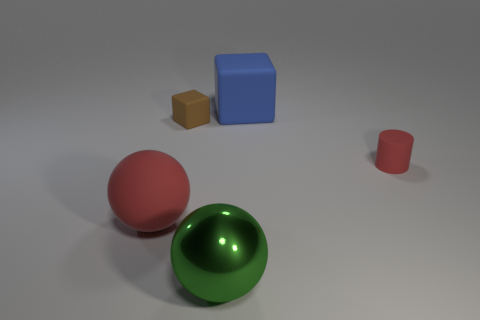There is a big ball that is the same color as the tiny matte cylinder; what is it made of?
Provide a succinct answer. Rubber. There is a object that is behind the small thing behind the small red matte object; what is its size?
Your answer should be compact. Large. Are there the same number of blue rubber things that are behind the shiny ball and shiny balls behind the rubber ball?
Offer a very short reply. No. Is there a cylinder that is in front of the big object in front of the big red matte object?
Ensure brevity in your answer.  No. There is a big matte thing in front of the tiny red matte cylinder that is on the right side of the metallic sphere; how many rubber things are behind it?
Make the answer very short. 3. Are there fewer tiny things than tiny red rubber objects?
Your answer should be very brief. No. Is the shape of the matte thing in front of the small red matte cylinder the same as the small rubber object that is on the left side of the small red cylinder?
Your response must be concise. No. The large matte sphere has what color?
Keep it short and to the point. Red. What number of metal objects are either blue spheres or big blue objects?
Provide a succinct answer. 0. There is a matte thing that is the same shape as the big green shiny thing; what is its color?
Give a very brief answer. Red. 